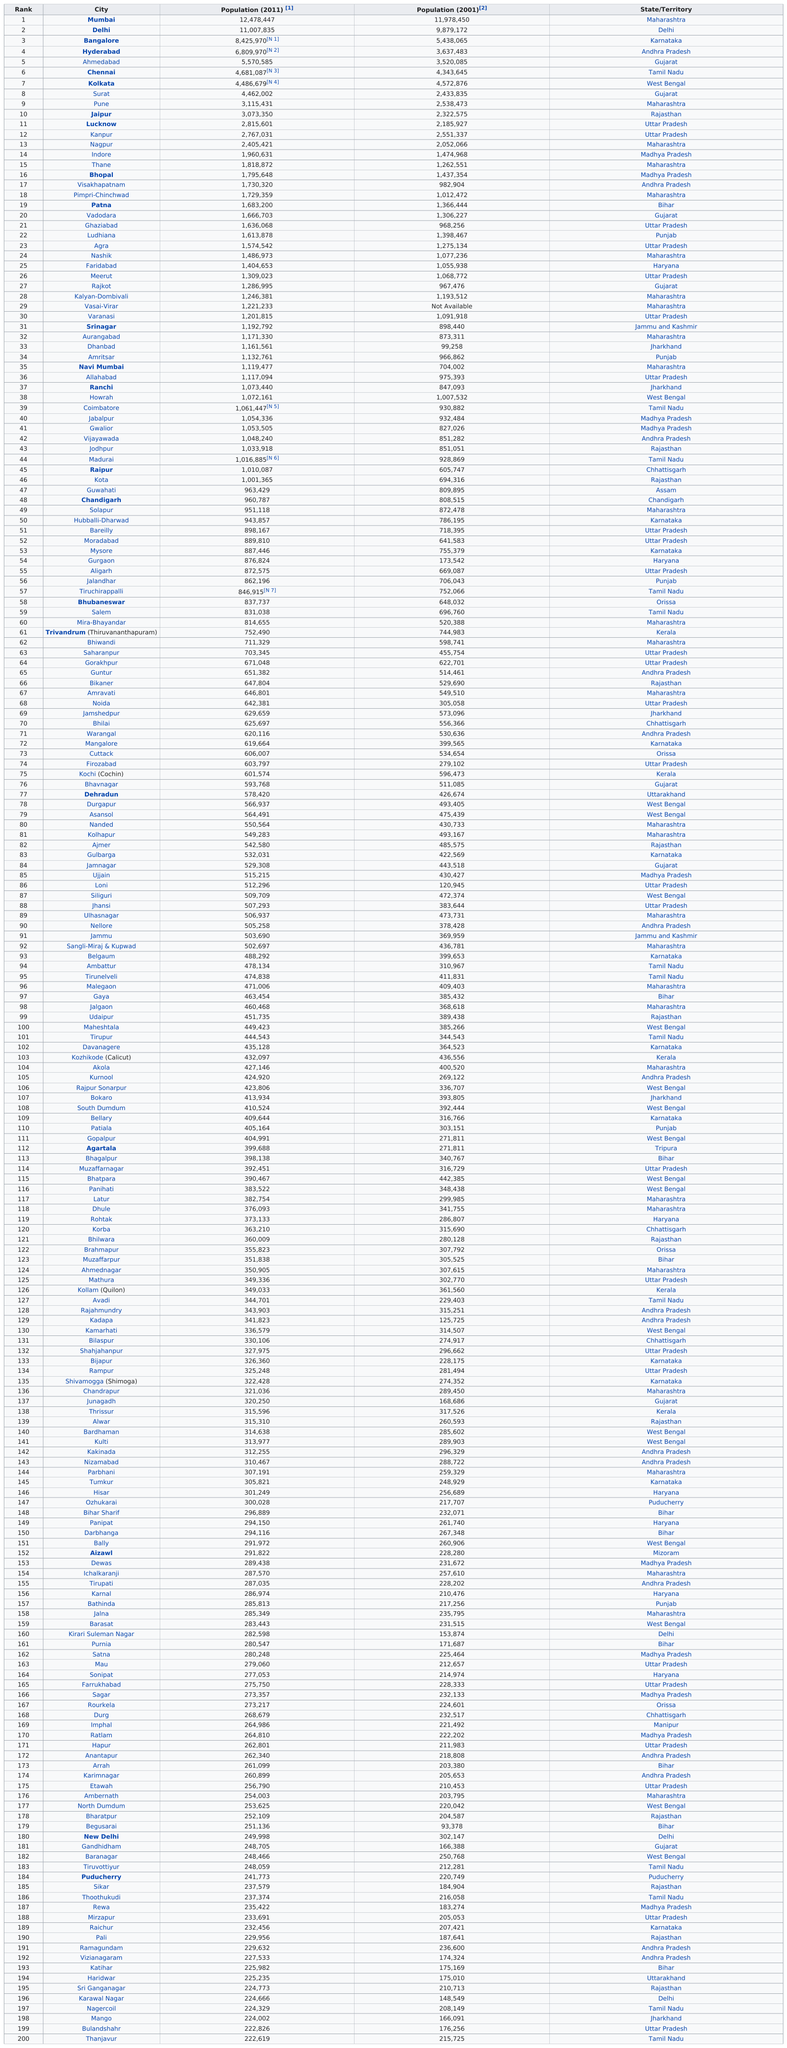Mention a couple of crucial points in this snapshot. Thanjavur, a city in Tamil Nadu, India, had a population of approximately 215,725 people in 2001. I am declaring that the city of Bhopal is not listed in the top 10. The cities of Ludhiana and Amritsar, located in the state of Punjab, have a population of over 1,000,000 each. The city of Begusarai was the last in population in the year 2001. Bulandshahr and Thanjavur are cities with populations less than 224,000 in 2011. 